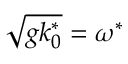<formula> <loc_0><loc_0><loc_500><loc_500>\sqrt { g k _ { 0 } ^ { * } } = \omega ^ { * }</formula> 